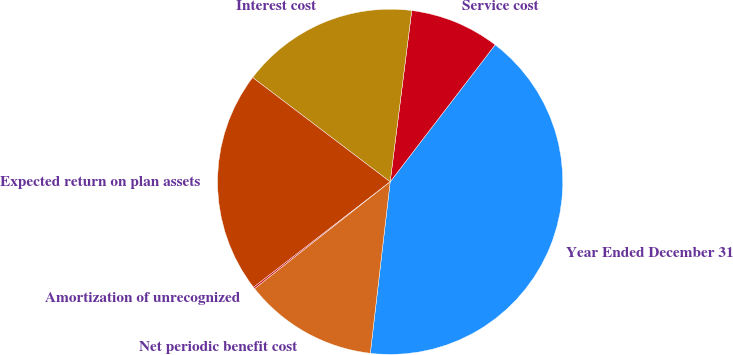Convert chart. <chart><loc_0><loc_0><loc_500><loc_500><pie_chart><fcel>Year Ended December 31<fcel>Service cost<fcel>Interest cost<fcel>Expected return on plan assets<fcel>Amortization of unrecognized<fcel>Net periodic benefit cost<nl><fcel>41.43%<fcel>8.41%<fcel>16.67%<fcel>20.79%<fcel>0.16%<fcel>12.54%<nl></chart> 